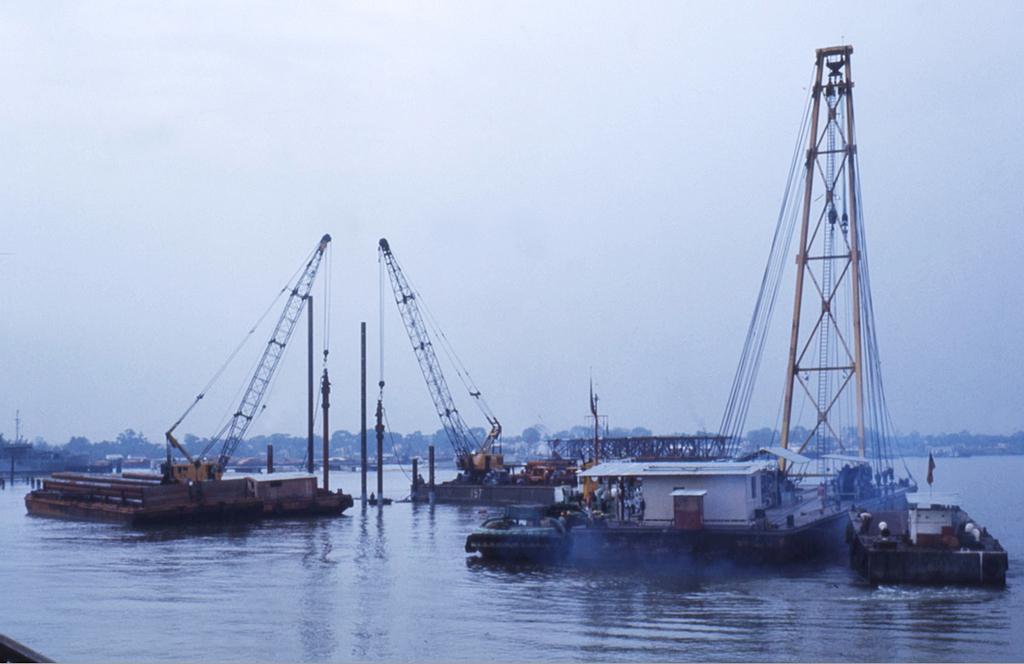Describe this image in one or two sentences. In this image there is a river, on that river there are boats, on that boat's there are cranes, in the background there are trees and the sky. 